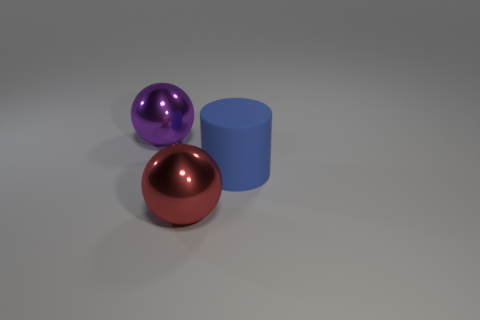Add 2 metal things. How many objects exist? 5 Subtract all balls. How many objects are left? 1 Subtract all big purple metallic objects. Subtract all large purple shiny spheres. How many objects are left? 1 Add 3 large purple balls. How many large purple balls are left? 4 Add 2 balls. How many balls exist? 4 Subtract 0 blue balls. How many objects are left? 3 